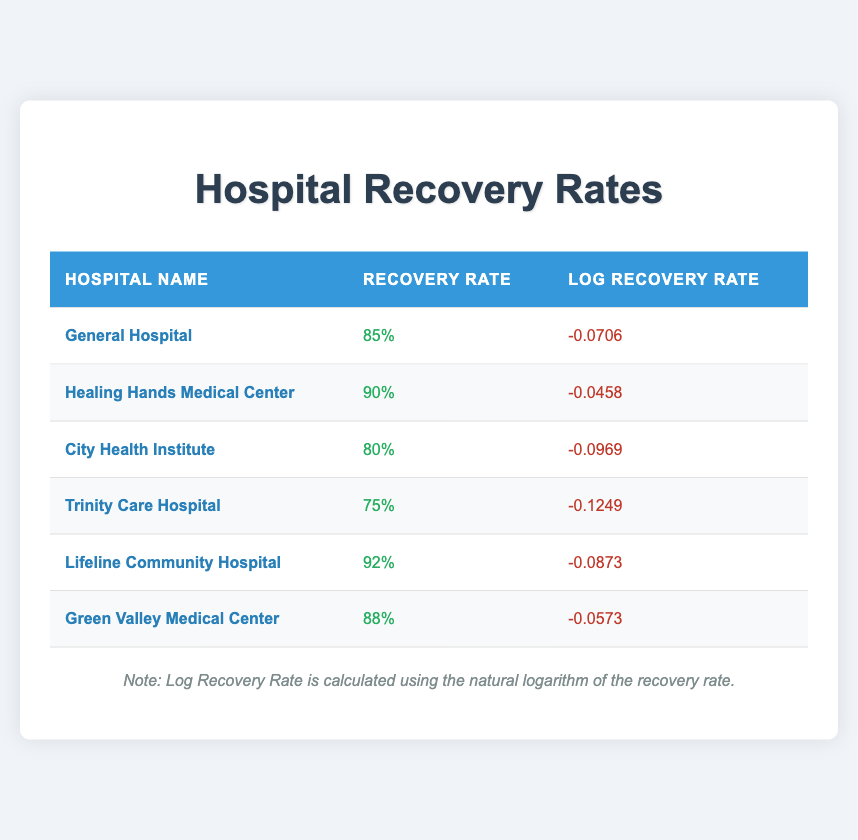What is the recovery rate of Lifeline Community Hospital? The recovery rate is listed directly in the table. For Lifeline Community Hospital, it shows 92%.
Answer: 92% Which hospital has the highest recovery rate? By checking the recovery rates in the table, Lifeline Community Hospital has the highest at 92%.
Answer: Lifeline Community Hospital How many hospitals have recovery rates higher than 85%? The hospitals with recovery rates above 85% are Healing Hands Medical Center (90%), Lifeline Community Hospital (92%), and Green Valley Medical Center (88%), totaling three hospitals.
Answer: 3 What is the average recovery rate of all hospitals listed? First, sum the recovery rates: 85 + 90 + 80 + 75 + 92 + 88 = 510. Then, divide by the number of hospitals (6): 510 / 6 = 85.
Answer: 85 Is the log recovery rate of City Health Institute lower than that of General Hospital? The log recovery rate for City Health Institute is -0.0969, and for General Hospital, it is -0.0706. Since -0.0969 is lower than -0.0706, the statement is true.
Answer: Yes Which hospital has the second-lowest log recovery rate? The log recovery rates are as follows: General Hospital (-0.0706), Healing Hands Medical Center (-0.0458), City Health Institute (-0.0969), Trinity Care Hospital (-0.1249), Lifeline Community Hospital (-0.0873), and Green Valley Medical Center (-0.0573). The second-lowest, after Healing Hands Medical Center, is General Hospital with -0.0706.
Answer: General Hospital Are there any hospitals with recovery rates below 80%? Yes, Trinity Care Hospital has a recovery rate of 75%, which is below 80%.
Answer: Yes What’s the difference in recovery rates between Healing Hands Medical Center and City Health Institute? Healing Hands Medical Center has a recovery rate of 90%, while City Health Institute has 80%. The difference is 90 - 80 = 10.
Answer: 10 